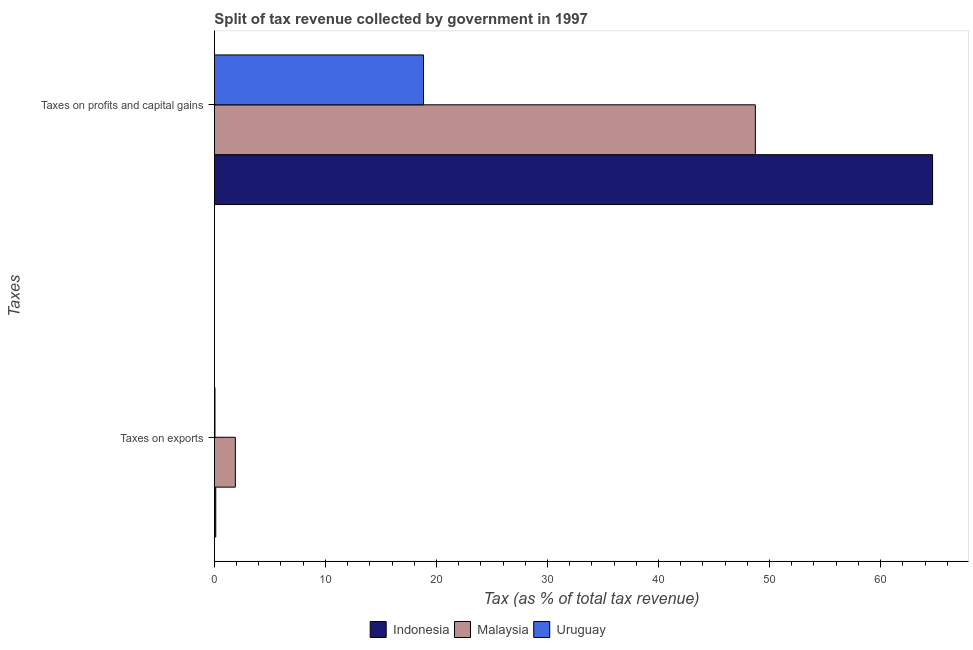How many different coloured bars are there?
Offer a very short reply. 3. How many bars are there on the 1st tick from the top?
Make the answer very short. 3. How many bars are there on the 2nd tick from the bottom?
Provide a succinct answer. 3. What is the label of the 2nd group of bars from the top?
Your answer should be compact. Taxes on exports. What is the percentage of revenue obtained from taxes on profits and capital gains in Uruguay?
Your answer should be compact. 18.84. Across all countries, what is the maximum percentage of revenue obtained from taxes on exports?
Your answer should be compact. 1.89. Across all countries, what is the minimum percentage of revenue obtained from taxes on exports?
Offer a very short reply. 0.06. In which country was the percentage of revenue obtained from taxes on profits and capital gains maximum?
Provide a short and direct response. Indonesia. In which country was the percentage of revenue obtained from taxes on profits and capital gains minimum?
Provide a succinct answer. Uruguay. What is the total percentage of revenue obtained from taxes on profits and capital gains in the graph?
Provide a succinct answer. 132.24. What is the difference between the percentage of revenue obtained from taxes on profits and capital gains in Malaysia and that in Indonesia?
Your answer should be compact. -15.96. What is the difference between the percentage of revenue obtained from taxes on exports in Malaysia and the percentage of revenue obtained from taxes on profits and capital gains in Indonesia?
Provide a short and direct response. -62.79. What is the average percentage of revenue obtained from taxes on profits and capital gains per country?
Ensure brevity in your answer.  44.08. What is the difference between the percentage of revenue obtained from taxes on exports and percentage of revenue obtained from taxes on profits and capital gains in Indonesia?
Make the answer very short. -64.55. In how many countries, is the percentage of revenue obtained from taxes on profits and capital gains greater than 16 %?
Offer a terse response. 3. What is the ratio of the percentage of revenue obtained from taxes on exports in Uruguay to that in Indonesia?
Provide a short and direct response. 0.43. Is the percentage of revenue obtained from taxes on exports in Malaysia less than that in Uruguay?
Offer a very short reply. No. What does the 3rd bar from the top in Taxes on profits and capital gains represents?
Your response must be concise. Indonesia. What does the 1st bar from the bottom in Taxes on profits and capital gains represents?
Provide a short and direct response. Indonesia. How many bars are there?
Ensure brevity in your answer.  6. Are all the bars in the graph horizontal?
Ensure brevity in your answer.  Yes. How many countries are there in the graph?
Provide a short and direct response. 3. What is the difference between two consecutive major ticks on the X-axis?
Provide a succinct answer. 10. Are the values on the major ticks of X-axis written in scientific E-notation?
Your answer should be compact. No. Does the graph contain any zero values?
Provide a succinct answer. No. What is the title of the graph?
Your response must be concise. Split of tax revenue collected by government in 1997. Does "Bangladesh" appear as one of the legend labels in the graph?
Your answer should be very brief. No. What is the label or title of the X-axis?
Offer a terse response. Tax (as % of total tax revenue). What is the label or title of the Y-axis?
Ensure brevity in your answer.  Taxes. What is the Tax (as % of total tax revenue) of Indonesia in Taxes on exports?
Keep it short and to the point. 0.13. What is the Tax (as % of total tax revenue) of Malaysia in Taxes on exports?
Make the answer very short. 1.89. What is the Tax (as % of total tax revenue) in Uruguay in Taxes on exports?
Ensure brevity in your answer.  0.06. What is the Tax (as % of total tax revenue) in Indonesia in Taxes on profits and capital gains?
Provide a succinct answer. 64.68. What is the Tax (as % of total tax revenue) of Malaysia in Taxes on profits and capital gains?
Give a very brief answer. 48.72. What is the Tax (as % of total tax revenue) of Uruguay in Taxes on profits and capital gains?
Keep it short and to the point. 18.84. Across all Taxes, what is the maximum Tax (as % of total tax revenue) in Indonesia?
Your answer should be compact. 64.68. Across all Taxes, what is the maximum Tax (as % of total tax revenue) of Malaysia?
Offer a very short reply. 48.72. Across all Taxes, what is the maximum Tax (as % of total tax revenue) of Uruguay?
Your answer should be very brief. 18.84. Across all Taxes, what is the minimum Tax (as % of total tax revenue) in Indonesia?
Your response must be concise. 0.13. Across all Taxes, what is the minimum Tax (as % of total tax revenue) in Malaysia?
Your answer should be very brief. 1.89. Across all Taxes, what is the minimum Tax (as % of total tax revenue) of Uruguay?
Offer a very short reply. 0.06. What is the total Tax (as % of total tax revenue) in Indonesia in the graph?
Your response must be concise. 64.81. What is the total Tax (as % of total tax revenue) of Malaysia in the graph?
Your answer should be compact. 50.61. What is the total Tax (as % of total tax revenue) of Uruguay in the graph?
Make the answer very short. 18.89. What is the difference between the Tax (as % of total tax revenue) in Indonesia in Taxes on exports and that in Taxes on profits and capital gains?
Provide a short and direct response. -64.55. What is the difference between the Tax (as % of total tax revenue) of Malaysia in Taxes on exports and that in Taxes on profits and capital gains?
Your answer should be compact. -46.83. What is the difference between the Tax (as % of total tax revenue) in Uruguay in Taxes on exports and that in Taxes on profits and capital gains?
Your response must be concise. -18.78. What is the difference between the Tax (as % of total tax revenue) of Indonesia in Taxes on exports and the Tax (as % of total tax revenue) of Malaysia in Taxes on profits and capital gains?
Make the answer very short. -48.59. What is the difference between the Tax (as % of total tax revenue) in Indonesia in Taxes on exports and the Tax (as % of total tax revenue) in Uruguay in Taxes on profits and capital gains?
Your answer should be compact. -18.71. What is the difference between the Tax (as % of total tax revenue) in Malaysia in Taxes on exports and the Tax (as % of total tax revenue) in Uruguay in Taxes on profits and capital gains?
Give a very brief answer. -16.95. What is the average Tax (as % of total tax revenue) in Indonesia per Taxes?
Offer a terse response. 32.41. What is the average Tax (as % of total tax revenue) of Malaysia per Taxes?
Make the answer very short. 25.31. What is the average Tax (as % of total tax revenue) of Uruguay per Taxes?
Your answer should be compact. 9.45. What is the difference between the Tax (as % of total tax revenue) of Indonesia and Tax (as % of total tax revenue) of Malaysia in Taxes on exports?
Provide a succinct answer. -1.76. What is the difference between the Tax (as % of total tax revenue) of Indonesia and Tax (as % of total tax revenue) of Uruguay in Taxes on exports?
Your response must be concise. 0.07. What is the difference between the Tax (as % of total tax revenue) in Malaysia and Tax (as % of total tax revenue) in Uruguay in Taxes on exports?
Ensure brevity in your answer.  1.84. What is the difference between the Tax (as % of total tax revenue) in Indonesia and Tax (as % of total tax revenue) in Malaysia in Taxes on profits and capital gains?
Keep it short and to the point. 15.96. What is the difference between the Tax (as % of total tax revenue) of Indonesia and Tax (as % of total tax revenue) of Uruguay in Taxes on profits and capital gains?
Offer a very short reply. 45.85. What is the difference between the Tax (as % of total tax revenue) of Malaysia and Tax (as % of total tax revenue) of Uruguay in Taxes on profits and capital gains?
Your answer should be compact. 29.89. What is the ratio of the Tax (as % of total tax revenue) in Indonesia in Taxes on exports to that in Taxes on profits and capital gains?
Ensure brevity in your answer.  0. What is the ratio of the Tax (as % of total tax revenue) in Malaysia in Taxes on exports to that in Taxes on profits and capital gains?
Offer a terse response. 0.04. What is the ratio of the Tax (as % of total tax revenue) of Uruguay in Taxes on exports to that in Taxes on profits and capital gains?
Provide a short and direct response. 0. What is the difference between the highest and the second highest Tax (as % of total tax revenue) of Indonesia?
Provide a short and direct response. 64.55. What is the difference between the highest and the second highest Tax (as % of total tax revenue) of Malaysia?
Ensure brevity in your answer.  46.83. What is the difference between the highest and the second highest Tax (as % of total tax revenue) of Uruguay?
Your answer should be very brief. 18.78. What is the difference between the highest and the lowest Tax (as % of total tax revenue) in Indonesia?
Make the answer very short. 64.55. What is the difference between the highest and the lowest Tax (as % of total tax revenue) of Malaysia?
Provide a short and direct response. 46.83. What is the difference between the highest and the lowest Tax (as % of total tax revenue) of Uruguay?
Your answer should be very brief. 18.78. 